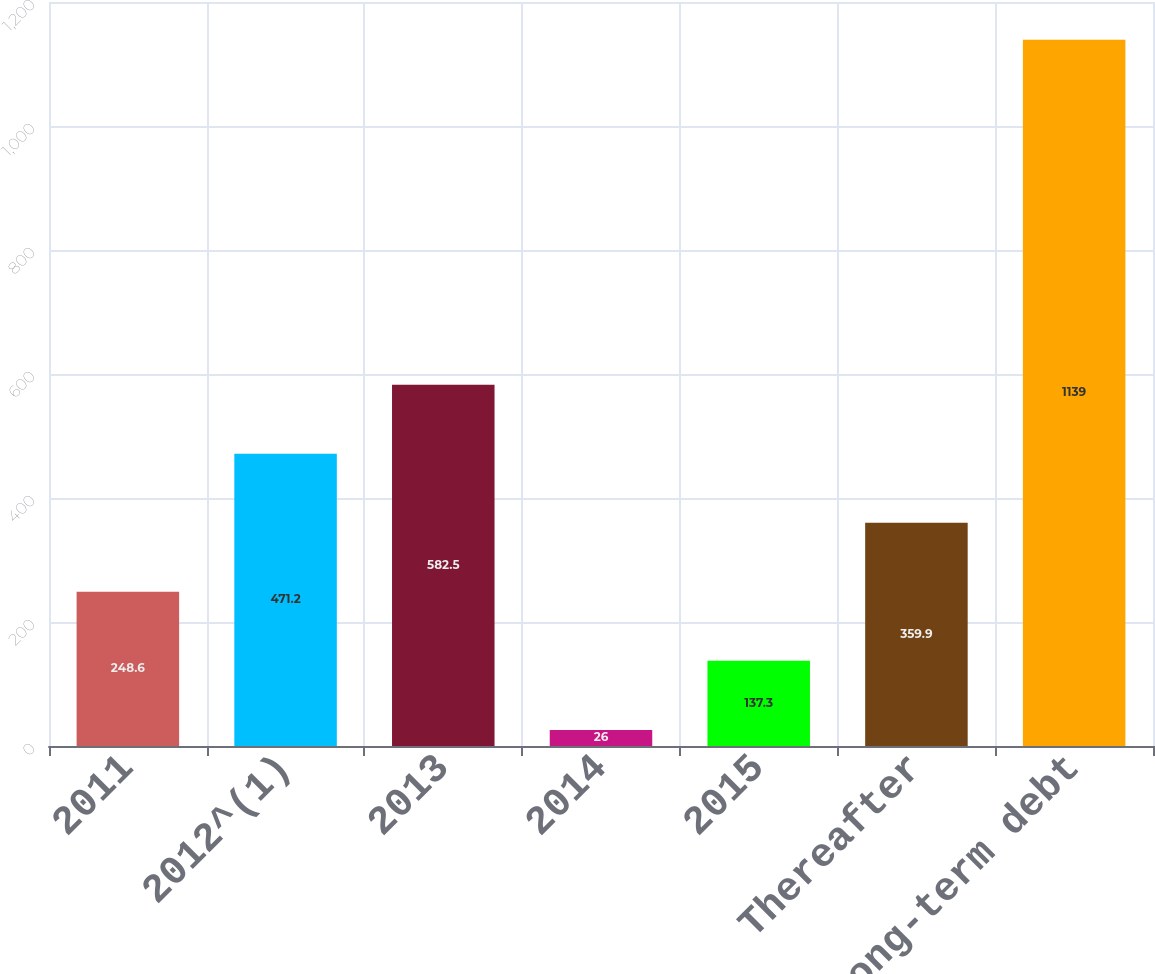Convert chart. <chart><loc_0><loc_0><loc_500><loc_500><bar_chart><fcel>2011<fcel>2012^(1)<fcel>2013<fcel>2014<fcel>2015<fcel>Thereafter<fcel>Total long-term debt<nl><fcel>248.6<fcel>471.2<fcel>582.5<fcel>26<fcel>137.3<fcel>359.9<fcel>1139<nl></chart> 